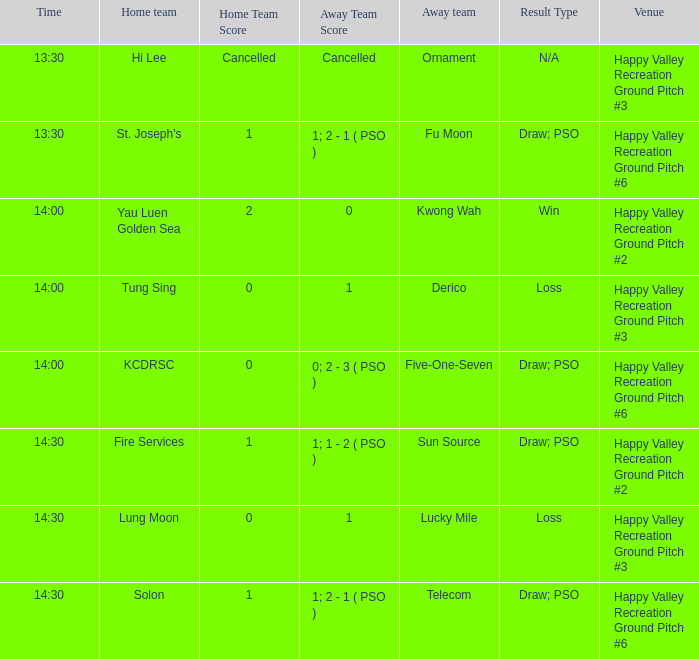What is the home team when kwong wah was the away team? Yau Luen Golden Sea. 